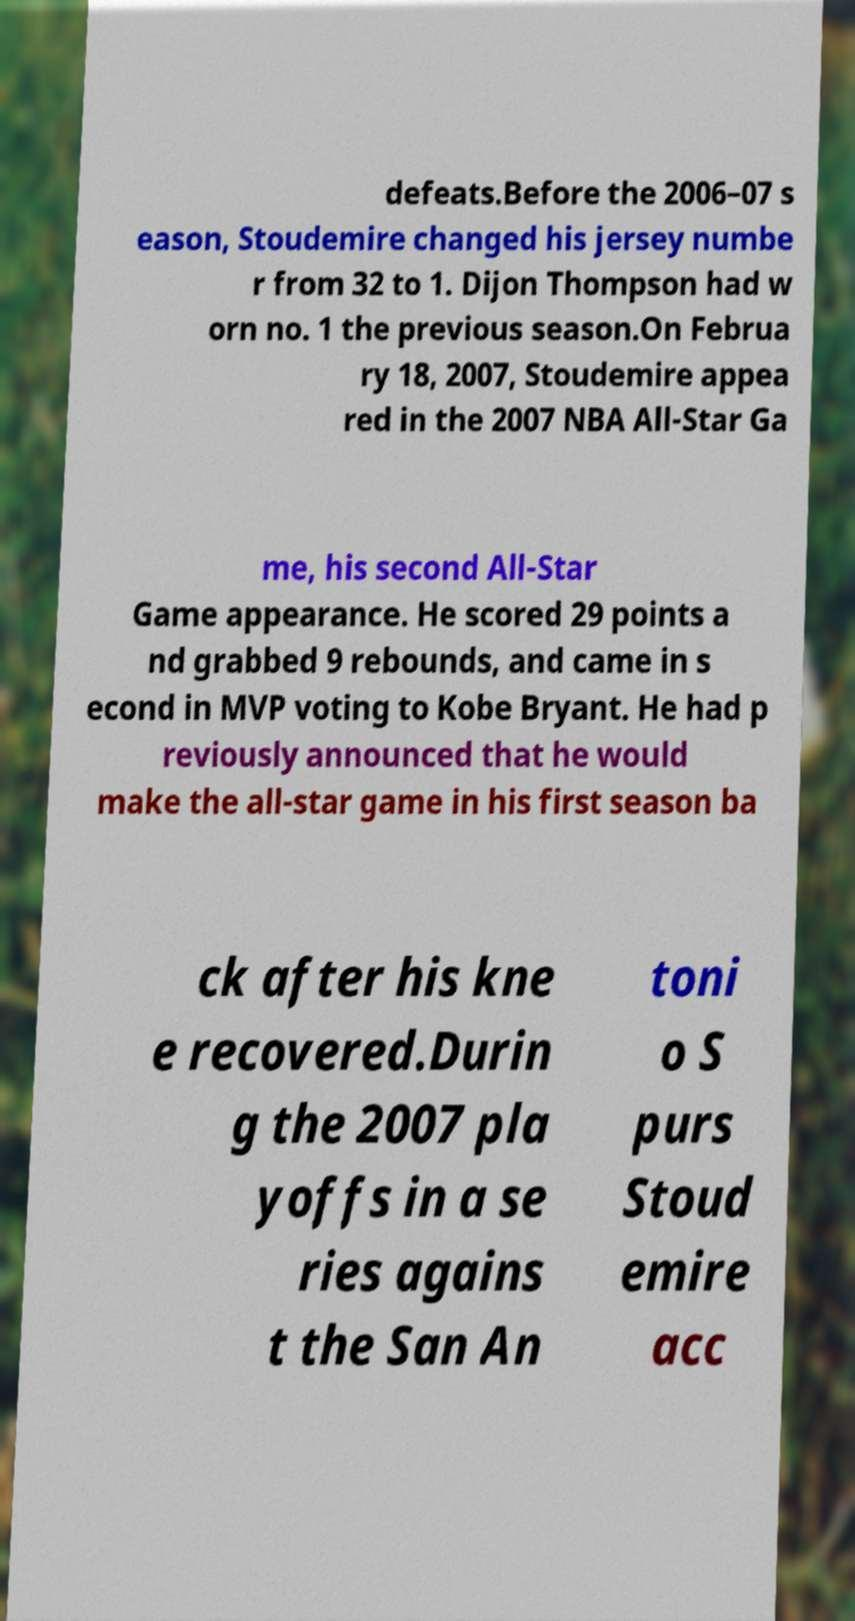For documentation purposes, I need the text within this image transcribed. Could you provide that? defeats.Before the 2006–07 s eason, Stoudemire changed his jersey numbe r from 32 to 1. Dijon Thompson had w orn no. 1 the previous season.On Februa ry 18, 2007, Stoudemire appea red in the 2007 NBA All-Star Ga me, his second All-Star Game appearance. He scored 29 points a nd grabbed 9 rebounds, and came in s econd in MVP voting to Kobe Bryant. He had p reviously announced that he would make the all-star game in his first season ba ck after his kne e recovered.Durin g the 2007 pla yoffs in a se ries agains t the San An toni o S purs Stoud emire acc 